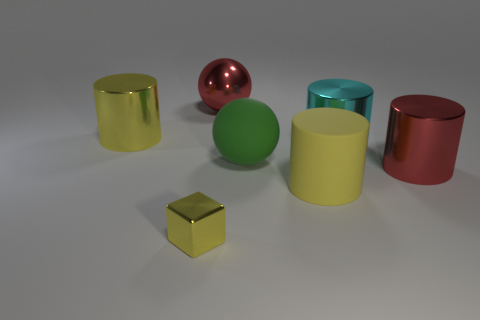Are there any other things that have the same size as the cube?
Offer a very short reply. No. Are the big yellow object in front of the green rubber sphere and the green object made of the same material?
Ensure brevity in your answer.  Yes. Is there a shiny block behind the big red metal thing to the left of the red thing on the right side of the big yellow matte cylinder?
Provide a succinct answer. No. How many cubes are big matte objects or tiny gray metallic things?
Make the answer very short. 0. There is a large yellow cylinder that is on the left side of the matte sphere; what material is it?
Provide a succinct answer. Metal. The cube that is the same color as the rubber cylinder is what size?
Your answer should be very brief. Small. There is a cylinder on the left side of the large rubber sphere; does it have the same color as the big matte thing in front of the large rubber sphere?
Your response must be concise. Yes. What number of objects are big things or large red metallic spheres?
Provide a short and direct response. 6. How many other objects are the same shape as the small object?
Ensure brevity in your answer.  0. Is the material of the yellow cylinder that is left of the big matte ball the same as the large yellow cylinder to the right of the yellow metallic cube?
Ensure brevity in your answer.  No. 